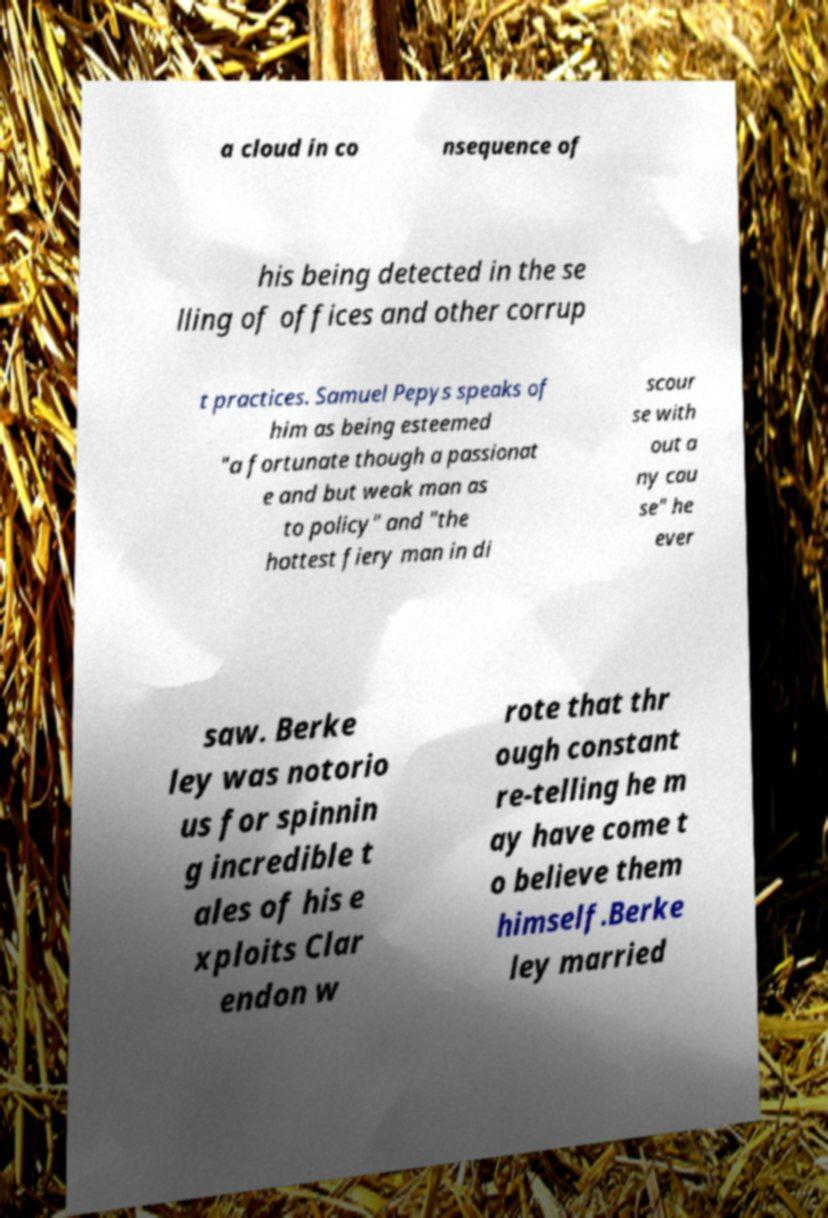What messages or text are displayed in this image? I need them in a readable, typed format. a cloud in co nsequence of his being detected in the se lling of offices and other corrup t practices. Samuel Pepys speaks of him as being esteemed "a fortunate though a passionat e and but weak man as to policy" and "the hottest fiery man in di scour se with out a ny cau se" he ever saw. Berke ley was notorio us for spinnin g incredible t ales of his e xploits Clar endon w rote that thr ough constant re-telling he m ay have come t o believe them himself.Berke ley married 